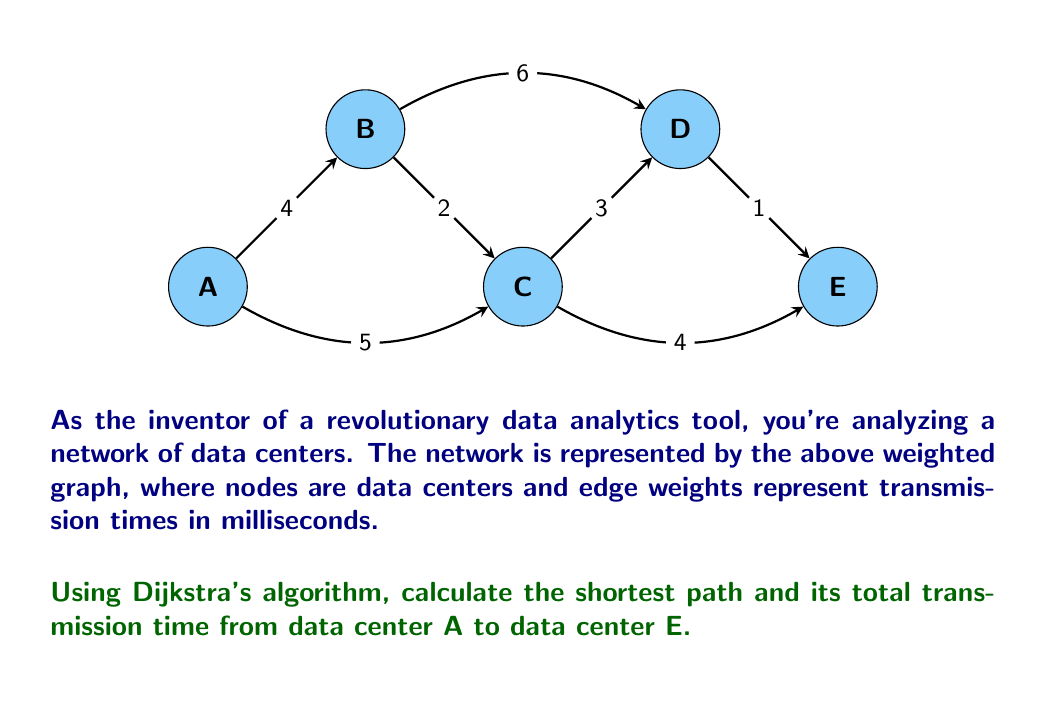Can you solve this math problem? Let's apply Dijkstra's algorithm step-by-step:

1) Initialize:
   - Distance to A: 0
   - Distance to all other nodes: $\infty$
   - Unvisited set: {A, B, C, D, E}

2) Start from node A:
   - Update distances: B(4), C(5)
   - Mark A as visited
   - Unvisited set: {B, C, D, E}

3) Select B (smallest distance from unvisited):
   - Update distances: D(10)
   - Mark B as visited
   - Unvisited set: {C, D, E}

4) Select C (smallest distance from unvisited):
   - Update distances: D(8), E(9)
   - Mark C as visited
   - Unvisited set: {D, E}

5) Select E (smallest distance from unvisited):
   - No updates needed
   - Mark E as visited
   - Unvisited set: {D}

6) Algorithm terminates as E is visited

The shortest path is A -> C -> E with a total transmission time of 9ms.

To reconstruct the path:
E <- C <- A
Answer: Path: A -> C -> E, Time: 9ms 